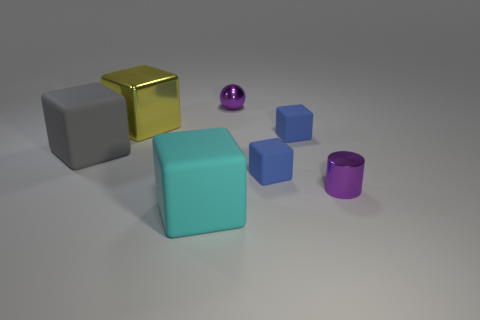Do the metallic sphere and the metal cube have the same color?
Keep it short and to the point. No. There is a purple object that is made of the same material as the small ball; what shape is it?
Offer a very short reply. Cylinder. There is a metal thing behind the yellow shiny thing; is its shape the same as the big yellow object?
Keep it short and to the point. No. What number of purple things are large objects or matte things?
Offer a terse response. 0. Are there an equal number of shiny cylinders that are behind the small sphere and matte cubes on the right side of the cyan matte object?
Your answer should be compact. No. The tiny cube in front of the large matte cube to the left of the large cube that is in front of the big gray thing is what color?
Make the answer very short. Blue. Is there any other thing that is the same color as the shiny cylinder?
Offer a terse response. Yes. What shape is the object that is the same color as the ball?
Give a very brief answer. Cylinder. How big is the metal thing that is to the left of the big cyan block?
Your answer should be very brief. Large. There is a cyan matte object that is the same size as the yellow shiny thing; what shape is it?
Ensure brevity in your answer.  Cube. 